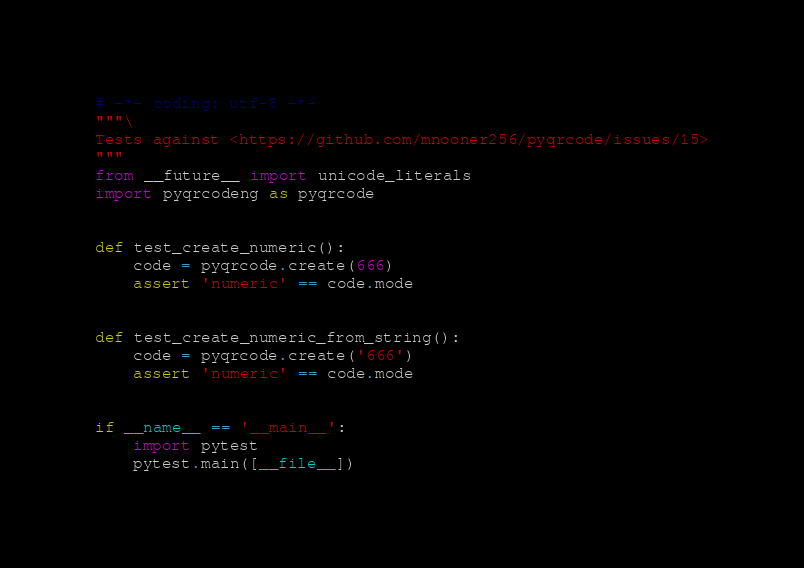<code> <loc_0><loc_0><loc_500><loc_500><_Python_># -*- coding: utf-8 -*-
"""\
Tests against <https://github.com/mnooner256/pyqrcode/issues/15>
"""
from __future__ import unicode_literals
import pyqrcodeng as pyqrcode


def test_create_numeric():
    code = pyqrcode.create(666)
    assert 'numeric' == code.mode


def test_create_numeric_from_string():
    code = pyqrcode.create('666')
    assert 'numeric' == code.mode


if __name__ == '__main__':
    import pytest
    pytest.main([__file__])
</code> 